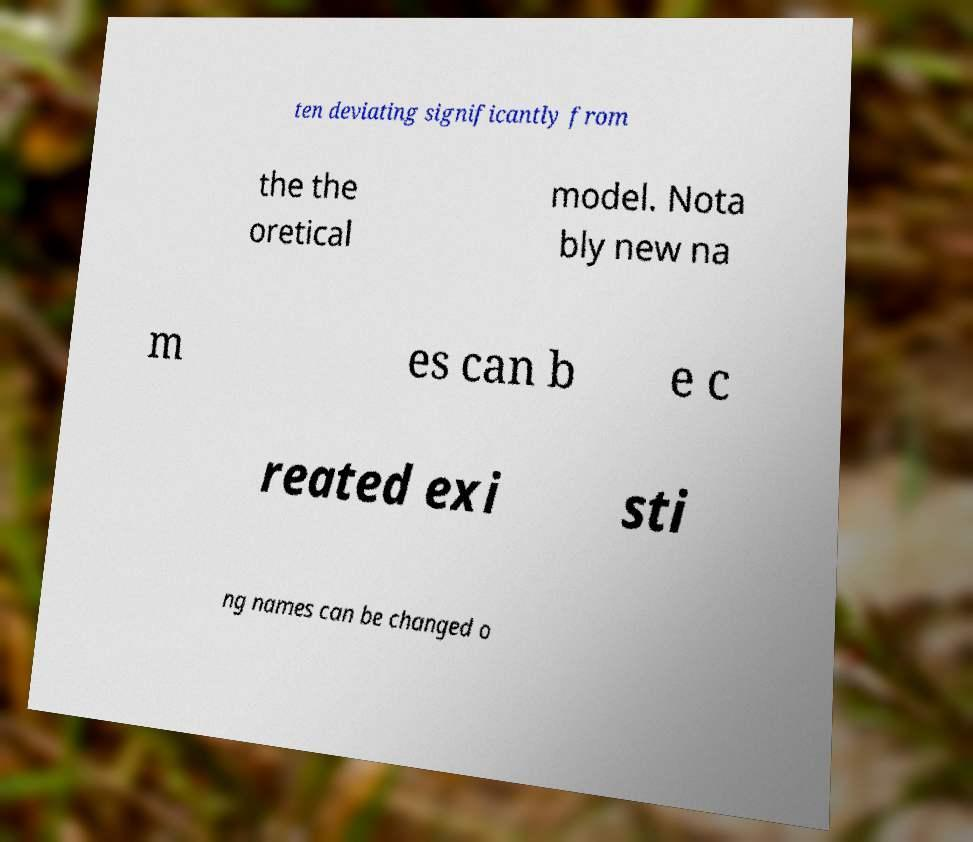I need the written content from this picture converted into text. Can you do that? ten deviating significantly from the the oretical model. Nota bly new na m es can b e c reated exi sti ng names can be changed o 